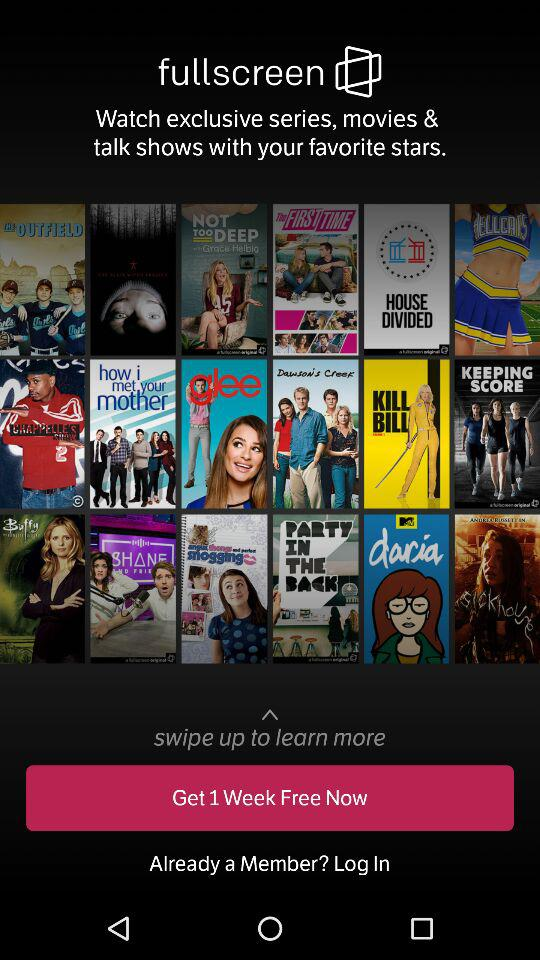What is the name of the application? The application name is "fullscreen". 